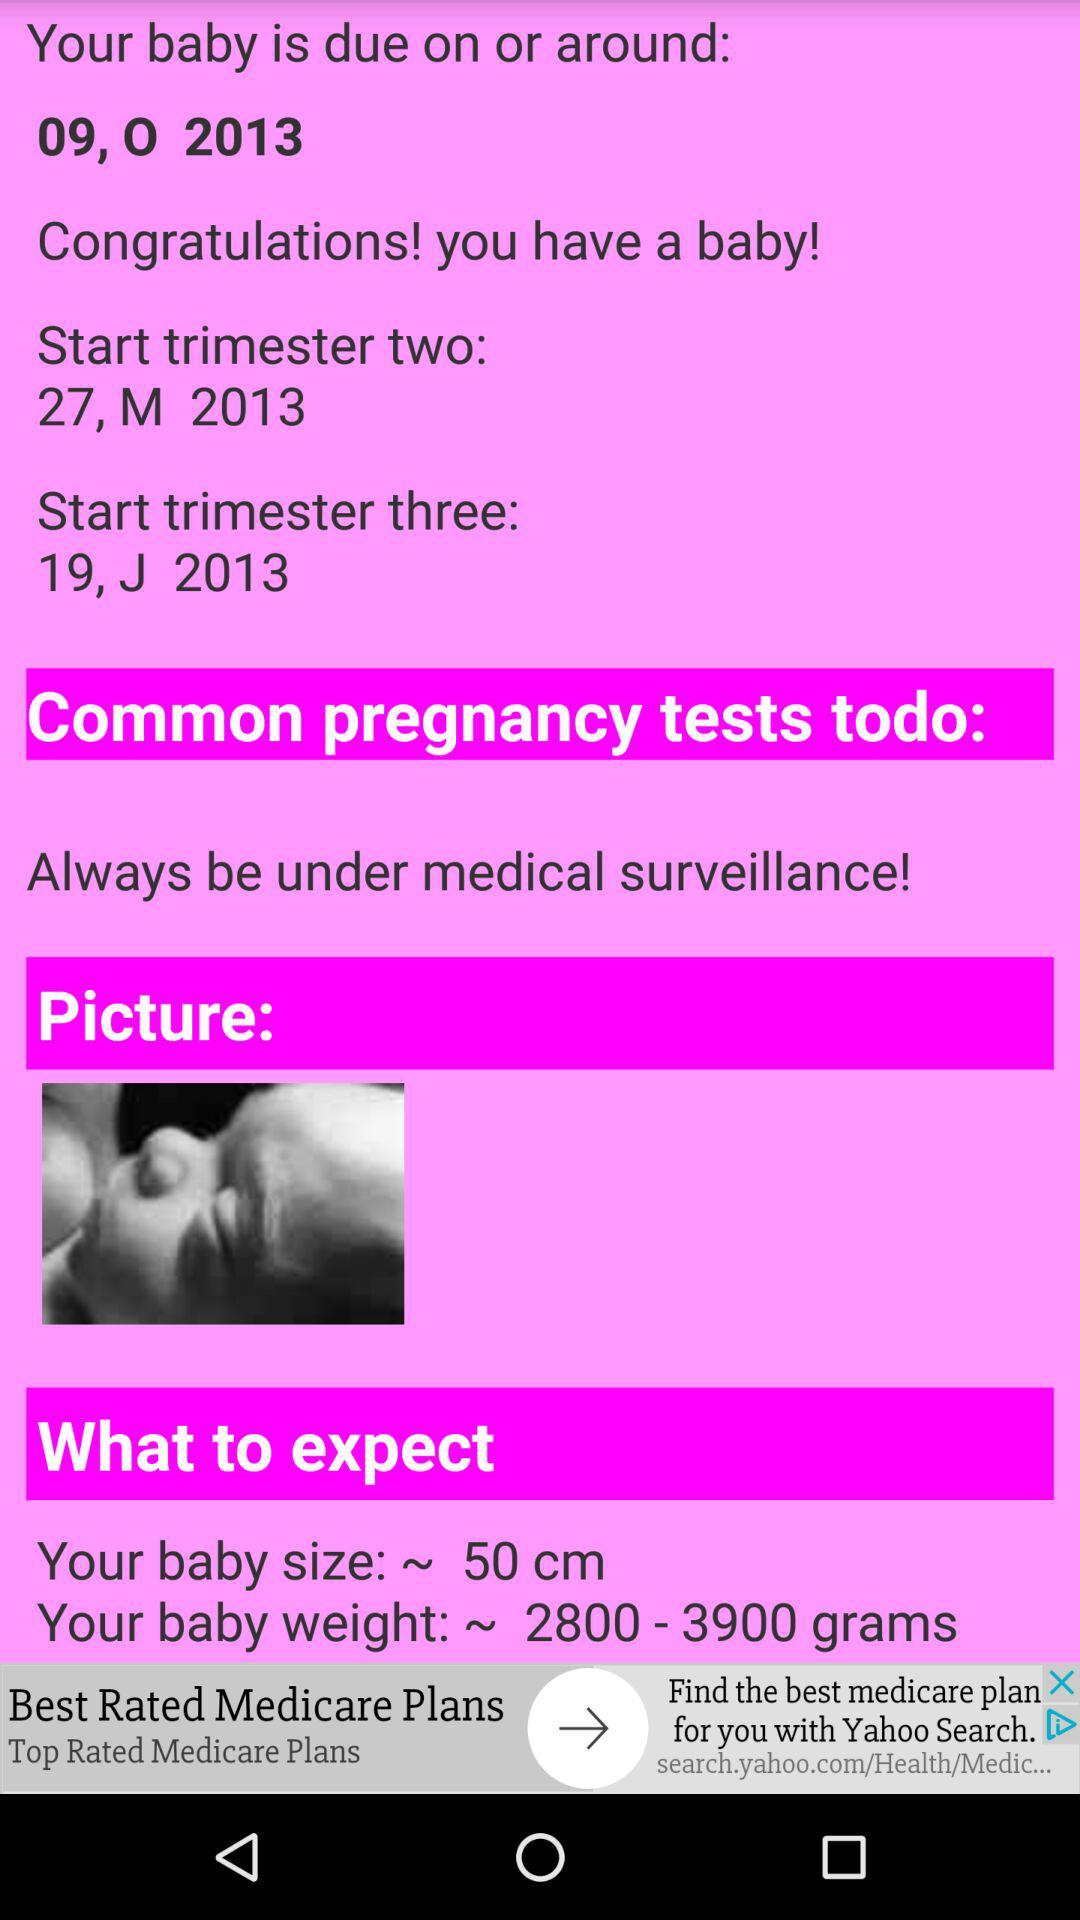When does trimester two begin? Trimester two starts on 27 March, 2013. 